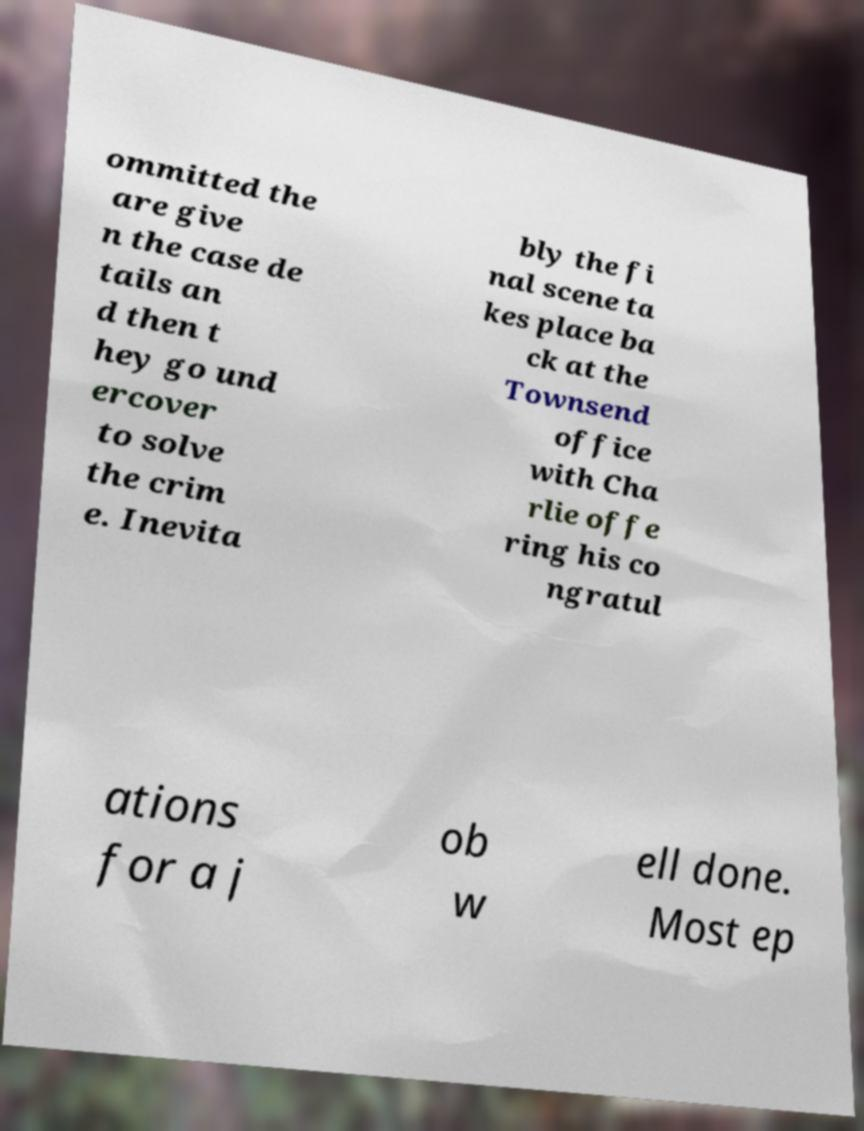There's text embedded in this image that I need extracted. Can you transcribe it verbatim? ommitted the are give n the case de tails an d then t hey go und ercover to solve the crim e. Inevita bly the fi nal scene ta kes place ba ck at the Townsend office with Cha rlie offe ring his co ngratul ations for a j ob w ell done. Most ep 